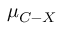<formula> <loc_0><loc_0><loc_500><loc_500>{ \mu } _ { C - X }</formula> 